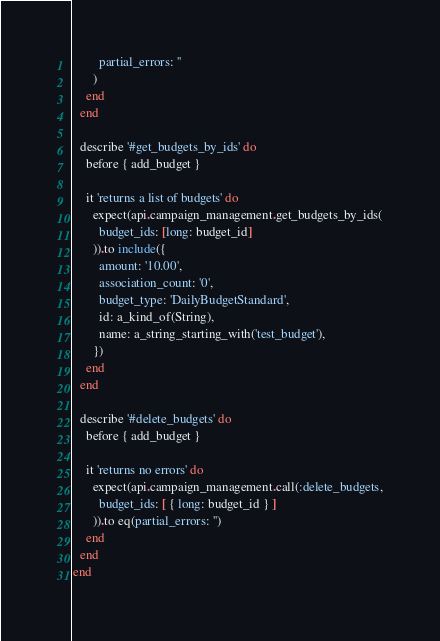<code> <loc_0><loc_0><loc_500><loc_500><_Ruby_>        partial_errors: ''
      )
    end
  end

  describe '#get_budgets_by_ids' do
    before { add_budget }

    it 'returns a list of budgets' do
      expect(api.campaign_management.get_budgets_by_ids(
        budget_ids: [long: budget_id]
      )).to include({
        amount: '10.00',
        association_count: '0',
        budget_type: 'DailyBudgetStandard',
        id: a_kind_of(String),
        name: a_string_starting_with('test_budget'),
      })
    end
  end

  describe '#delete_budgets' do
    before { add_budget }

    it 'returns no errors' do
      expect(api.campaign_management.call(:delete_budgets,
        budget_ids: [ { long: budget_id } ]
      )).to eq(partial_errors: '')
    end
  end
end
</code> 